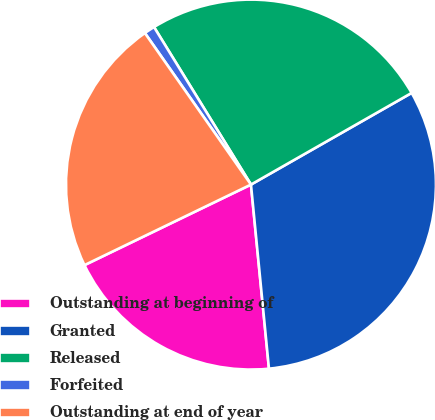Convert chart to OTSL. <chart><loc_0><loc_0><loc_500><loc_500><pie_chart><fcel>Outstanding at beginning of<fcel>Granted<fcel>Released<fcel>Forfeited<fcel>Outstanding at end of year<nl><fcel>19.38%<fcel>31.7%<fcel>25.53%<fcel>0.94%<fcel>22.45%<nl></chart> 